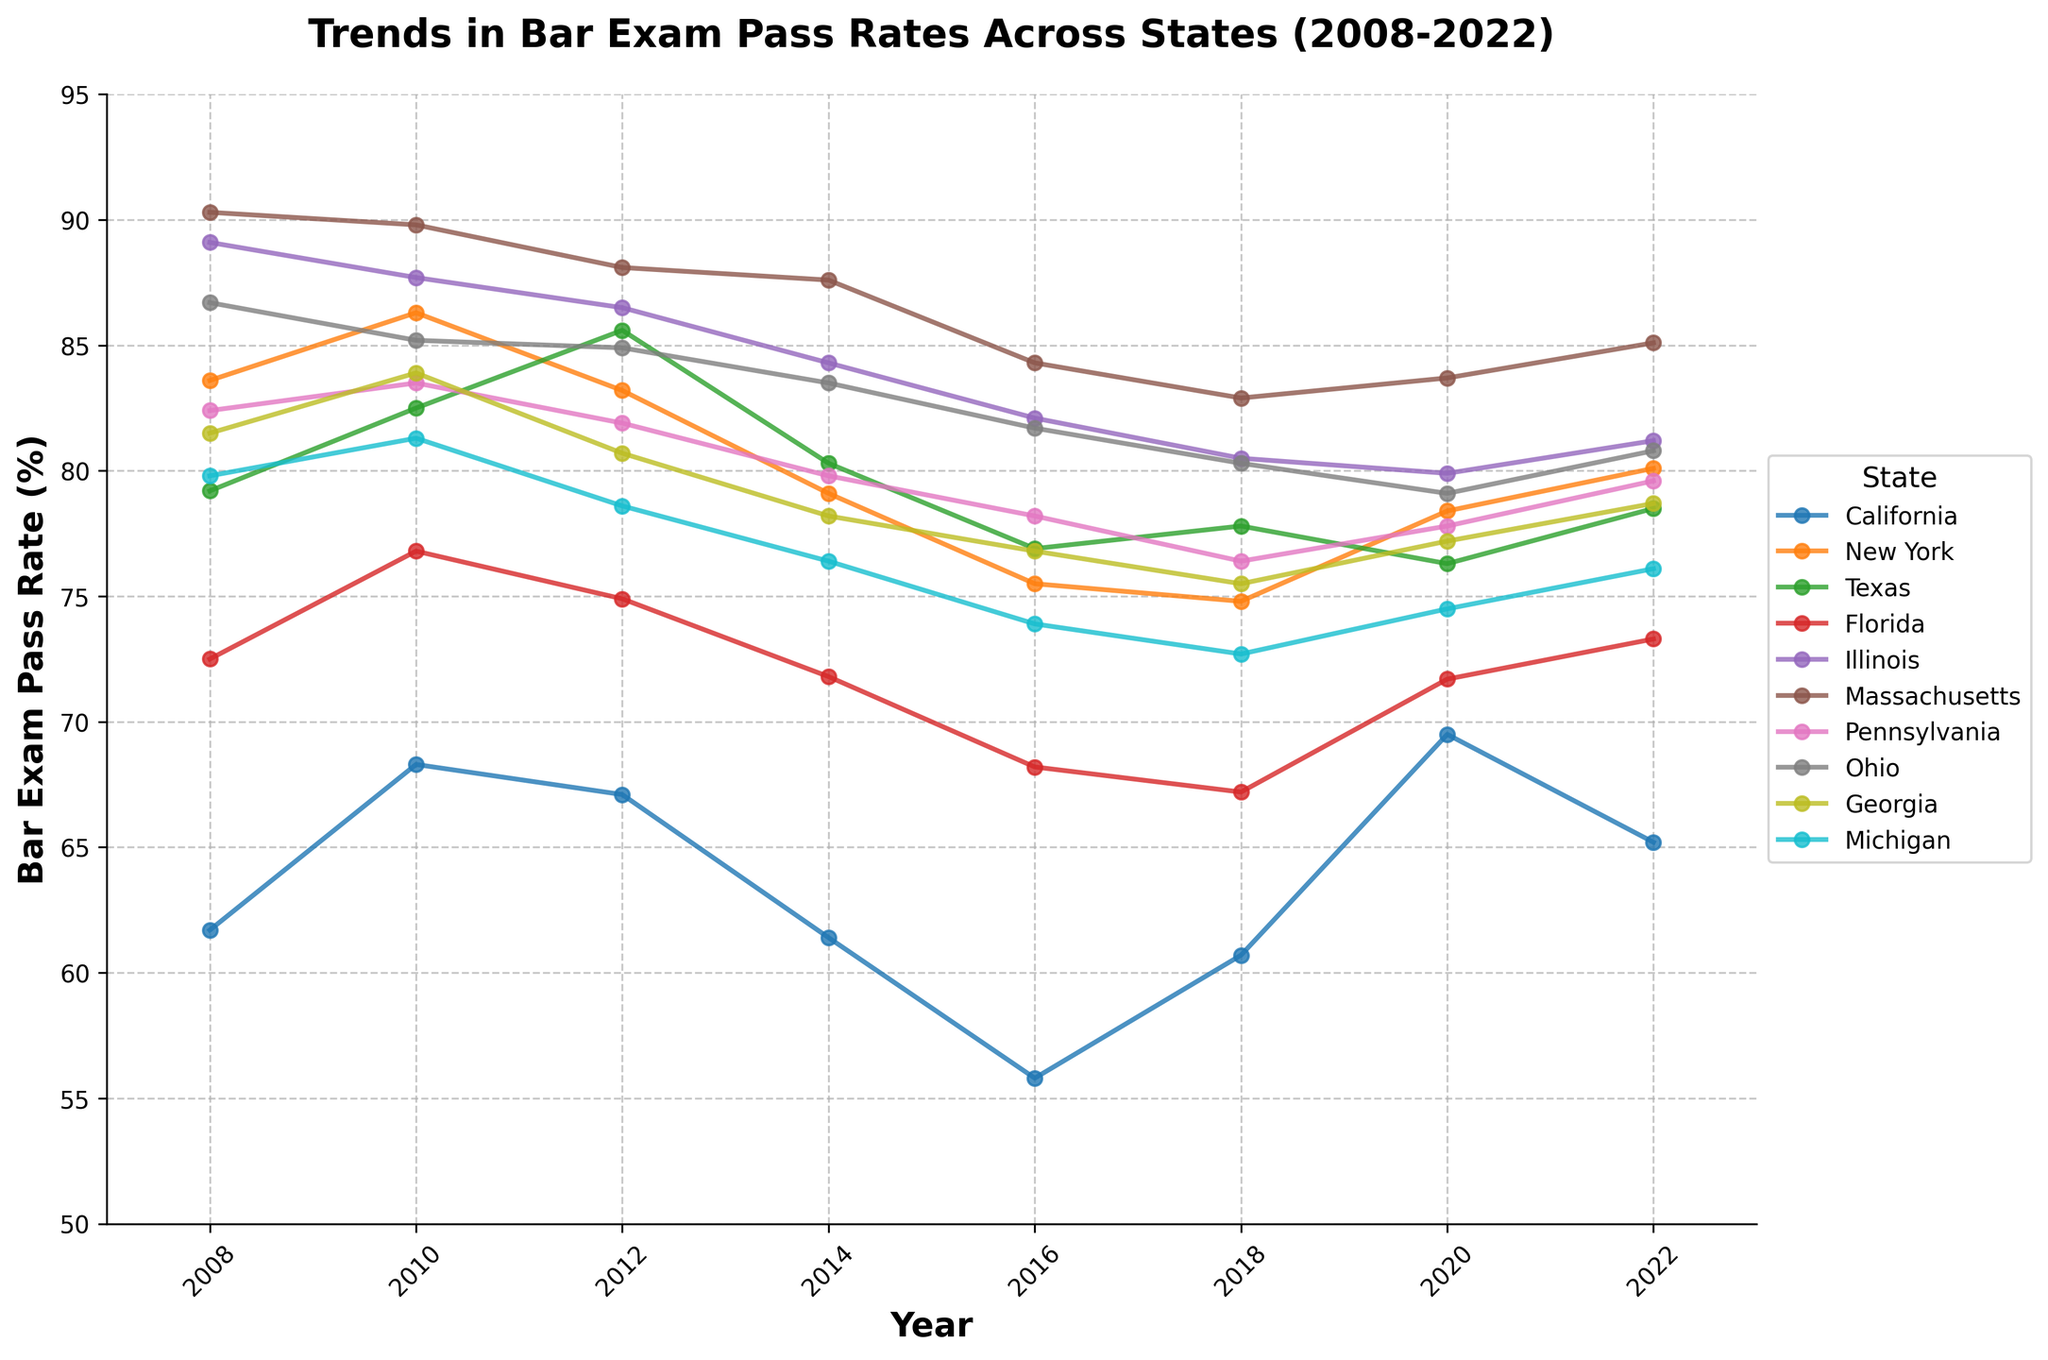Which state had the highest bar exam pass rate in 2010? To find the state with the highest pass rate in 2010, we compare the values for all states in that year. Massachusetts had the highest pass rate with 89.8%.
Answer: Massachusetts How did the bar exam pass rates for California change from 2008 to 2022? Observe the trend line for California from 2008 to 2022. In 2008, the pass rate was 61.7%, increased to a peak of 69.5% in 2020, and then slightly decreased to 65.2% in 2022.
Answer: Increased initially, peaked, then decreased slightly Which state showed the most consistent pass rate trend over the 15 years? Consistency implies minimal fluctuation. Massachusetts shows the most consistent trend, with pass rates fluctuating minorly between 90.3% and 82.9%.
Answer: Massachusetts Between 2012 and 2016, which state had the largest decrease in bar exam pass rates? Looking at the values between 2012 and 2016, the largest decrease can be seen in California, with a drop from 67.1% to 55.8%.
Answer: California What is the average bar exam pass rate for New York over the 15 years? To find the average, sum the values for New York from 2008 to 2022: 83.6 + 86.3 + 83.2 + 79.1 + 75.5 + 74.8 + 78.4 + 80.1 = 641, then divide by 8 (number of years): 641/8 = 80.125%.
Answer: 80.125% Compare the trends in bar exam pass rates between Texas and Florida. Texas and Florida both show variations, with Texas peaking in 2012 at 85.6% and later decreasing to 78.5%, whereas Florida shows a more consistent downward trend reaching up to 73.3% in 2022.
Answer: Texas varied more, Florida consistently decreased Which state had the lowest bar exam pass rate in 2018, and what was it? By comparing bar exam pass rates in 2018, California had the lowest rate at 60.7%.
Answer: California, 60.7% Did any state have an increasing trend in bar exam pass rates from 2018 to 2022? Checking the trend lines from 2018 to 2022, New York's pass rates increased from 74.8% to 80.1%, indicating an upward trend.
Answer: New York How did the pass rates for Ohio change between 2008 and 2014, and between 2014 and 2022? From 2008 to 2014, Ohio's pass rate slightly decreased from 86.7% to 83.5%. From 2014 to 2022, it continued to decrease to 80.8%.
Answer: Slight decrease, then continued decrease Which states had a higher pass rate in 2022 compared to 2016? Comparing 2022 to 2016: California (65.2% vs. 55.8%), New York (80.1% vs. 75.5%), and Florida (73.3% vs. 68.2%) had higher pass rates in 2022.
Answer: California, New York, Florida 